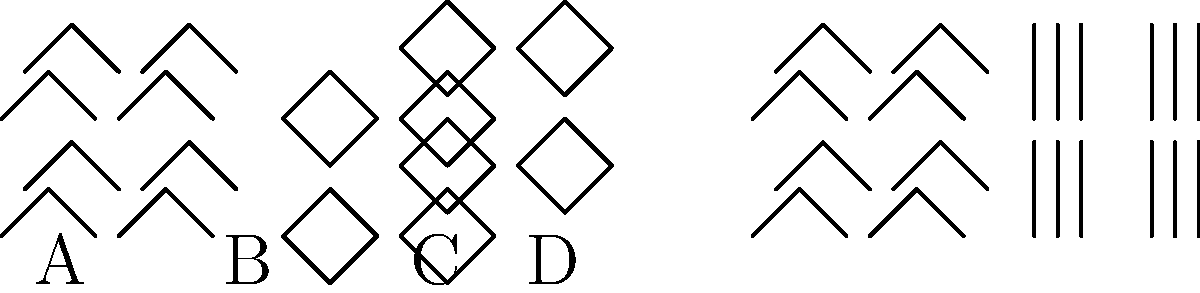As a fashion model, you're often asked to identify fabric patterns quickly. In the image above, which pattern is commonly associated with formal menswear and is characterized by its thin, vertical lines? Let's analyze each pattern in the image:

1. Pattern A: This is a herringbone pattern, characterized by a distinctive V-shaped weaving pattern. It's often used in tweed jackets and overcoats.

2. Pattern B: This is a houndstooth pattern, featuring broken checks or abstract four-pointed shapes. It's popular in fall and winter clothing.

3. Pattern C: This is a chevron pattern, showing a repeated V-shape. It's common in both casual and formal wear.

4. Pattern D: This is a pinstripe pattern, distinguished by very thin, parallel vertical lines on a solid background. It's most commonly associated with formal menswear, particularly business suits.

Given the question's focus on thin, vertical lines and association with formal menswear, the correct answer is the pinstripe pattern, labeled as D in the image.
Answer: Pinstripe (D) 